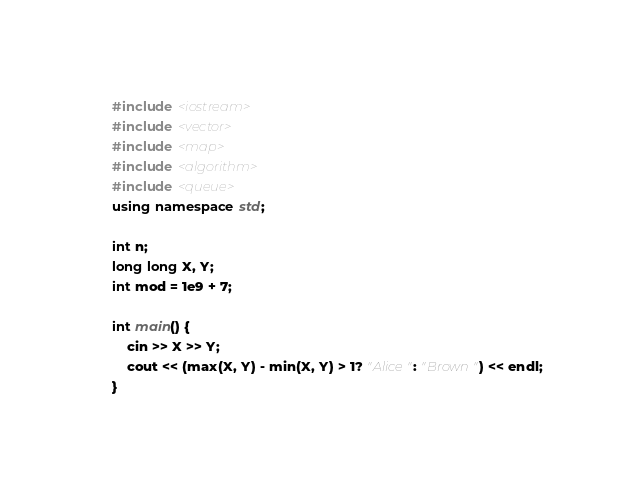<code> <loc_0><loc_0><loc_500><loc_500><_C++_>#include <iostream>
#include <vector>
#include <map>
#include <algorithm>
#include <queue>
using namespace std;

int n;
long long X, Y;
int mod = 1e9 + 7;

int main() {
    cin >> X >> Y;
    cout << (max(X, Y) - min(X, Y) > 1? "Alice": "Brown") << endl;
}
</code> 